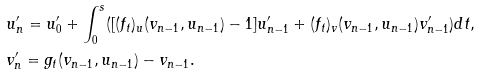<formula> <loc_0><loc_0><loc_500><loc_500>& u _ { n } ^ { \prime } = u _ { 0 } ^ { \prime } + \int _ { 0 } ^ { s } ( [ ( f _ { t } ) _ { u } ( v _ { n - 1 } , u _ { n - 1 } ) - 1 ] u _ { n - 1 } ^ { \prime } + ( f _ { t } ) _ { v } ( v _ { n - 1 } , u _ { n - 1 } ) v _ { n - 1 } ^ { \prime } ) d t , \\ & v _ { n } ^ { \prime } = g _ { t } ( v _ { n - 1 } , u _ { n - 1 } ) - v _ { n - 1 } .</formula> 